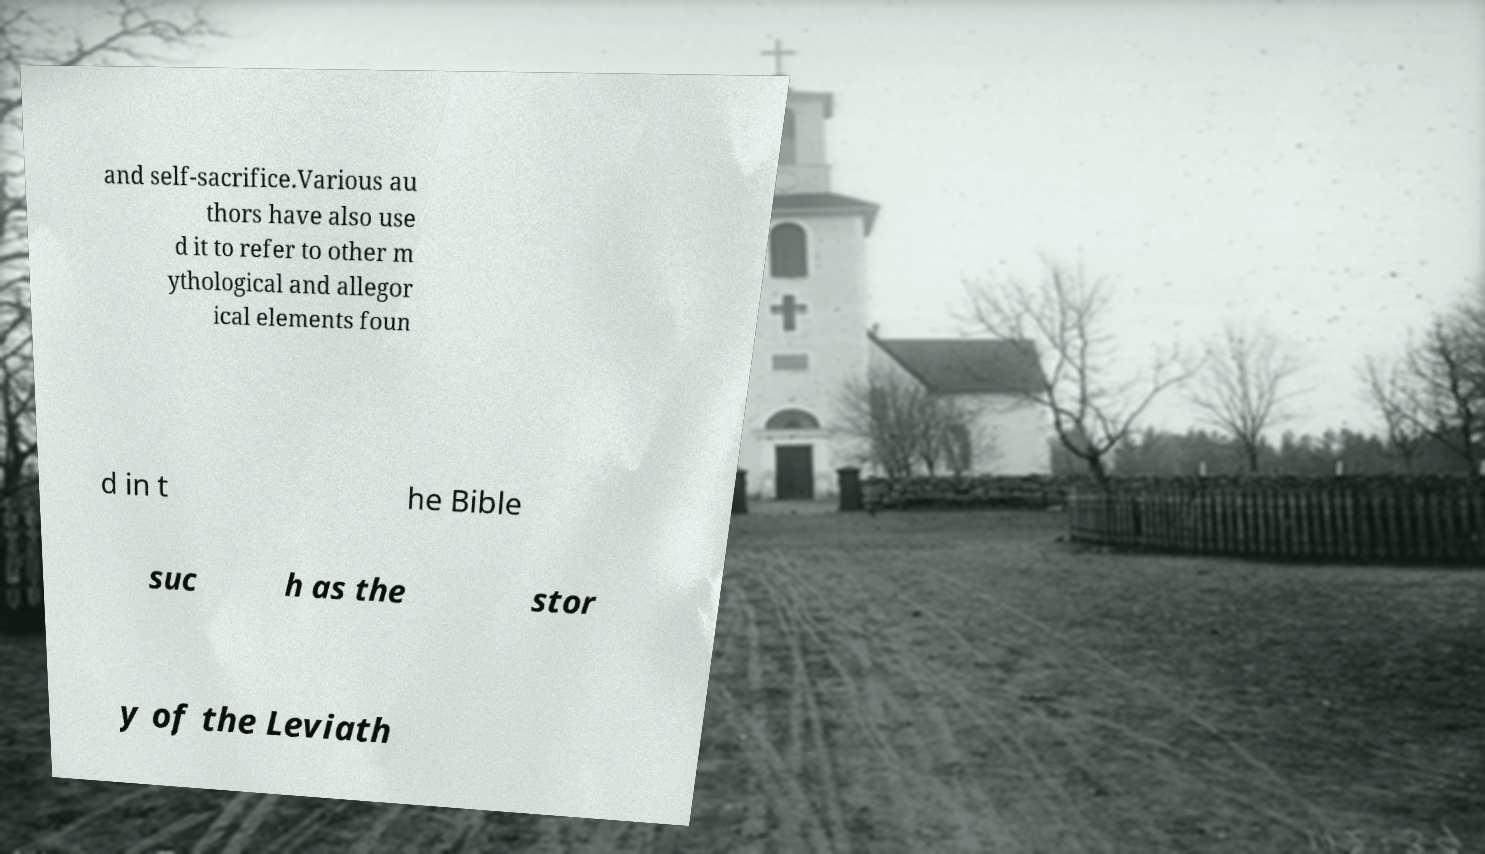Can you accurately transcribe the text from the provided image for me? and self-sacrifice.Various au thors have also use d it to refer to other m ythological and allegor ical elements foun d in t he Bible suc h as the stor y of the Leviath 